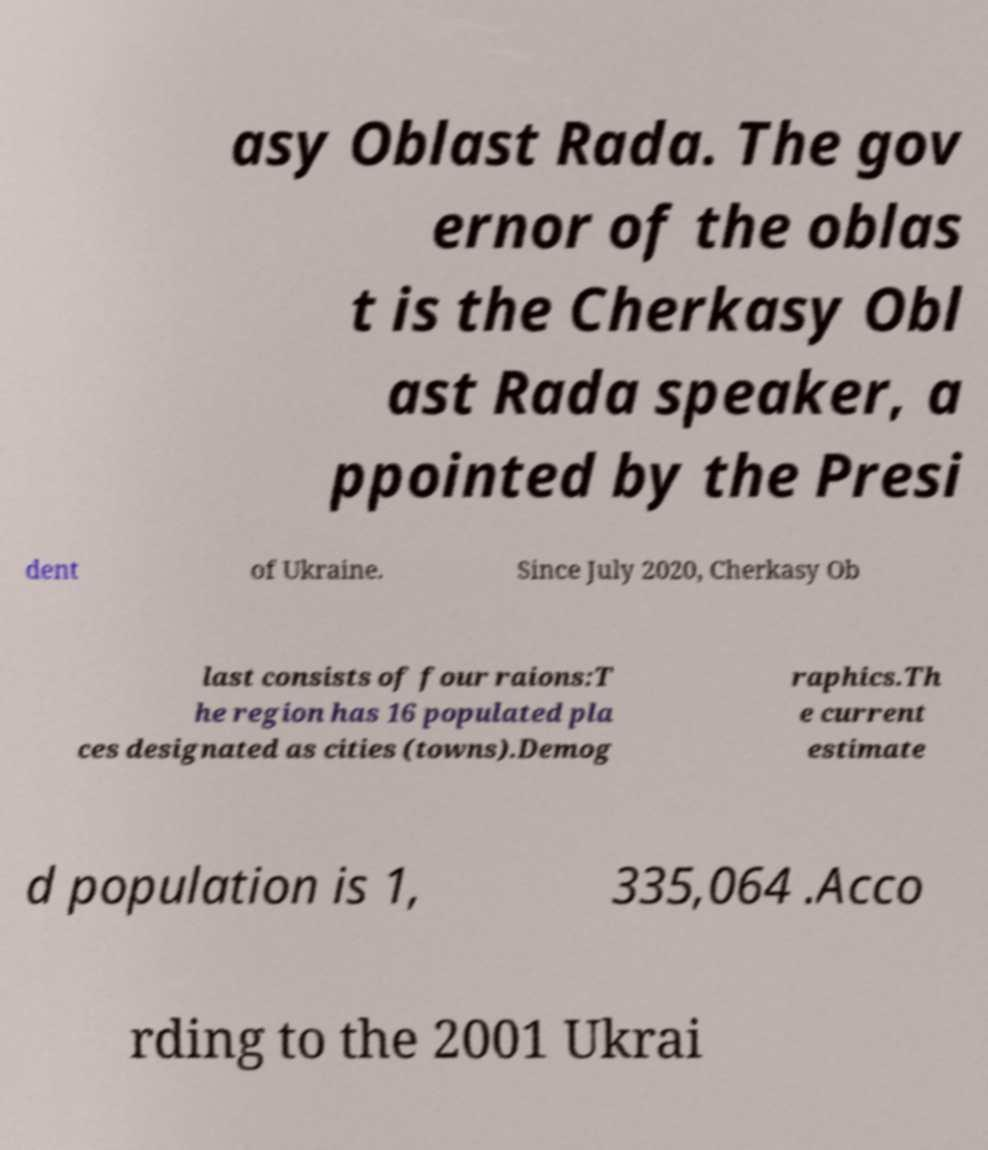Can you accurately transcribe the text from the provided image for me? asy Oblast Rada. The gov ernor of the oblas t is the Cherkasy Obl ast Rada speaker, a ppointed by the Presi dent of Ukraine. Since July 2020, Cherkasy Ob last consists of four raions:T he region has 16 populated pla ces designated as cities (towns).Demog raphics.Th e current estimate d population is 1, 335,064 .Acco rding to the 2001 Ukrai 